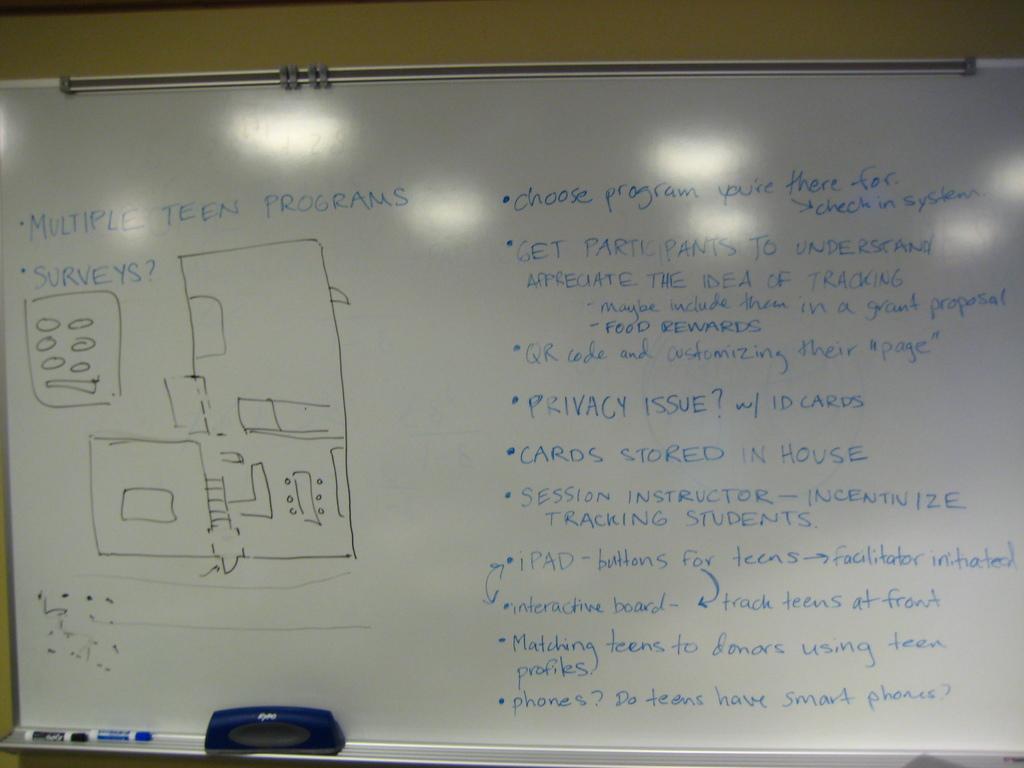What is written on the board beside privacy issue?
Keep it short and to the point. W/ id cards. What are there multiple of?
Provide a succinct answer. Teen programs. 